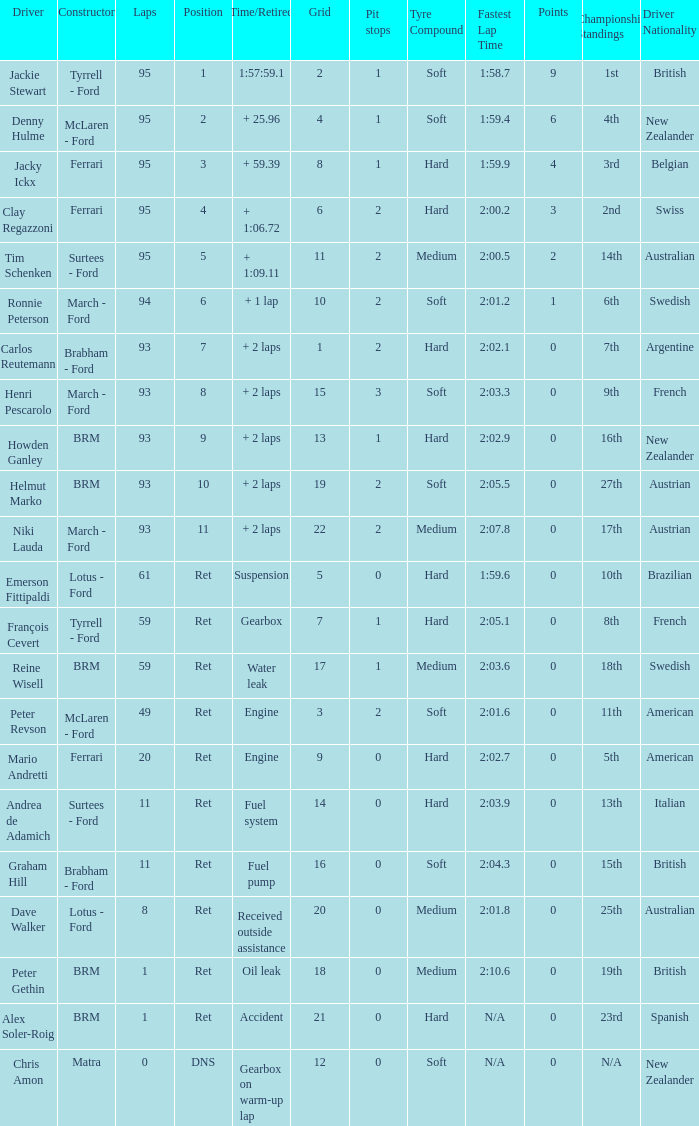Which grid has less than 11 laps, and a Time/Retired of accident? 21.0. 